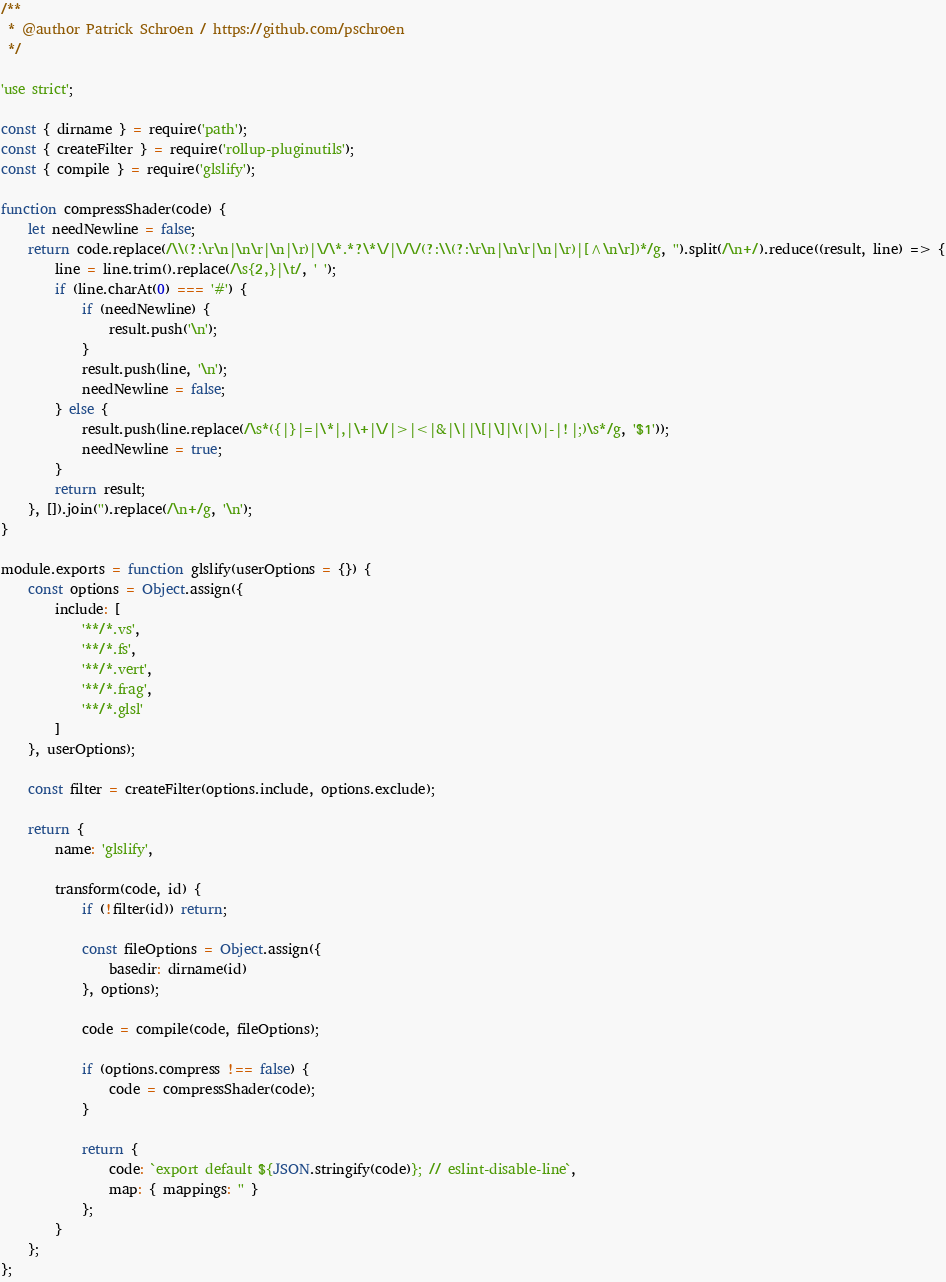Convert code to text. <code><loc_0><loc_0><loc_500><loc_500><_JavaScript_>/**
 * @author Patrick Schroen / https://github.com/pschroen
 */

'use strict';

const { dirname } = require('path');
const { createFilter } = require('rollup-pluginutils');
const { compile } = require('glslify');

function compressShader(code) {
    let needNewline = false;
    return code.replace(/\\(?:\r\n|\n\r|\n|\r)|\/\*.*?\*\/|\/\/(?:\\(?:\r\n|\n\r|\n|\r)|[^\n\r])*/g, '').split(/\n+/).reduce((result, line) => {
        line = line.trim().replace(/\s{2,}|\t/, ' ');
        if (line.charAt(0) === '#') {
            if (needNewline) {
                result.push('\n');
            }
            result.push(line, '\n');
            needNewline = false;
        } else {
            result.push(line.replace(/\s*({|}|=|\*|,|\+|\/|>|<|&|\||\[|\]|\(|\)|-|!|;)\s*/g, '$1'));
            needNewline = true;
        }
        return result;
    }, []).join('').replace(/\n+/g, '\n');
}

module.exports = function glslify(userOptions = {}) {
    const options = Object.assign({
        include: [
            '**/*.vs',
            '**/*.fs',
            '**/*.vert',
            '**/*.frag',
            '**/*.glsl'
        ]
    }, userOptions);

    const filter = createFilter(options.include, options.exclude);

    return {
        name: 'glslify',

        transform(code, id) {
            if (!filter(id)) return;

            const fileOptions = Object.assign({
                basedir: dirname(id)
            }, options);

            code = compile(code, fileOptions);

            if (options.compress !== false) {
                code = compressShader(code);
            }

            return {
                code: `export default ${JSON.stringify(code)}; // eslint-disable-line`,
                map: { mappings: '' }
            };
        }
    };
};
</code> 